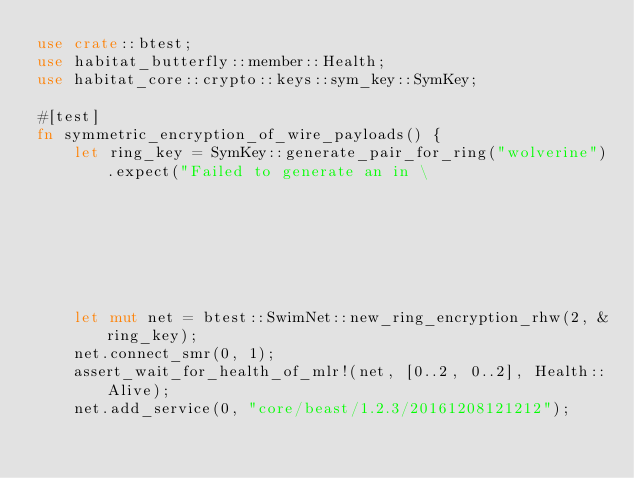<code> <loc_0><loc_0><loc_500><loc_500><_Rust_>use crate::btest;
use habitat_butterfly::member::Health;
use habitat_core::crypto::keys::sym_key::SymKey;

#[test]
fn symmetric_encryption_of_wire_payloads() {
    let ring_key = SymKey::generate_pair_for_ring("wolverine").expect("Failed to generate an in \
                                                                       memory symkey");
    let mut net = btest::SwimNet::new_ring_encryption_rhw(2, &ring_key);
    net.connect_smr(0, 1);
    assert_wait_for_health_of_mlr!(net, [0..2, 0..2], Health::Alive);
    net.add_service(0, "core/beast/1.2.3/20161208121212");</code> 